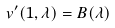<formula> <loc_0><loc_0><loc_500><loc_500>v ^ { \prime } ( 1 , \lambda ) = B ( \lambda )</formula> 